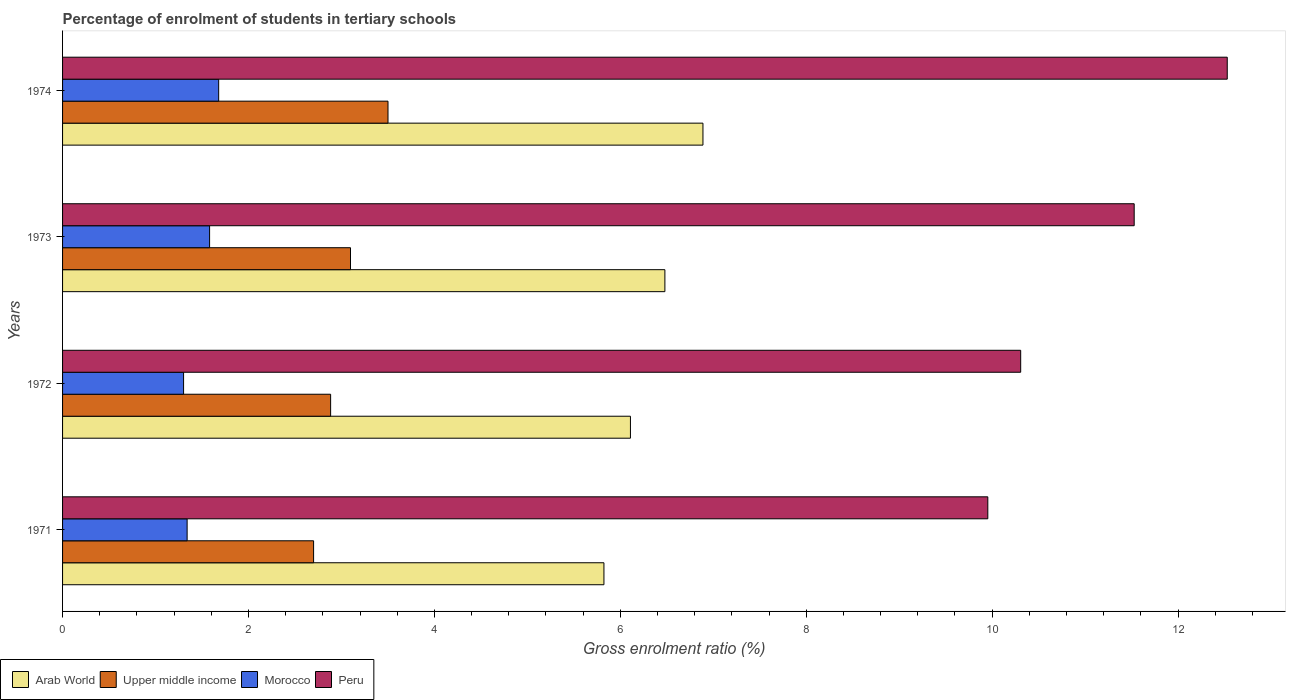How many different coloured bars are there?
Your response must be concise. 4. How many bars are there on the 1st tick from the top?
Offer a terse response. 4. What is the percentage of students enrolled in tertiary schools in Peru in 1971?
Provide a succinct answer. 9.95. Across all years, what is the maximum percentage of students enrolled in tertiary schools in Morocco?
Ensure brevity in your answer.  1.68. Across all years, what is the minimum percentage of students enrolled in tertiary schools in Morocco?
Offer a terse response. 1.3. In which year was the percentage of students enrolled in tertiary schools in Upper middle income maximum?
Your answer should be very brief. 1974. In which year was the percentage of students enrolled in tertiary schools in Upper middle income minimum?
Ensure brevity in your answer.  1971. What is the total percentage of students enrolled in tertiary schools in Upper middle income in the graph?
Your answer should be very brief. 12.18. What is the difference between the percentage of students enrolled in tertiary schools in Morocco in 1971 and that in 1972?
Your answer should be very brief. 0.04. What is the difference between the percentage of students enrolled in tertiary schools in Upper middle income in 1971 and the percentage of students enrolled in tertiary schools in Morocco in 1972?
Make the answer very short. 1.4. What is the average percentage of students enrolled in tertiary schools in Arab World per year?
Make the answer very short. 6.33. In the year 1973, what is the difference between the percentage of students enrolled in tertiary schools in Arab World and percentage of students enrolled in tertiary schools in Upper middle income?
Your answer should be compact. 3.38. In how many years, is the percentage of students enrolled in tertiary schools in Morocco greater than 5.6 %?
Your answer should be very brief. 0. What is the ratio of the percentage of students enrolled in tertiary schools in Arab World in 1972 to that in 1973?
Your response must be concise. 0.94. Is the percentage of students enrolled in tertiary schools in Arab World in 1971 less than that in 1974?
Your response must be concise. Yes. Is the difference between the percentage of students enrolled in tertiary schools in Arab World in 1971 and 1972 greater than the difference between the percentage of students enrolled in tertiary schools in Upper middle income in 1971 and 1972?
Keep it short and to the point. No. What is the difference between the highest and the second highest percentage of students enrolled in tertiary schools in Upper middle income?
Give a very brief answer. 0.4. What is the difference between the highest and the lowest percentage of students enrolled in tertiary schools in Peru?
Your answer should be very brief. 2.58. Is it the case that in every year, the sum of the percentage of students enrolled in tertiary schools in Peru and percentage of students enrolled in tertiary schools in Morocco is greater than the sum of percentage of students enrolled in tertiary schools in Upper middle income and percentage of students enrolled in tertiary schools in Arab World?
Offer a terse response. Yes. What does the 3rd bar from the top in 1973 represents?
Offer a very short reply. Upper middle income. What does the 2nd bar from the bottom in 1973 represents?
Make the answer very short. Upper middle income. Are the values on the major ticks of X-axis written in scientific E-notation?
Ensure brevity in your answer.  No. Where does the legend appear in the graph?
Your response must be concise. Bottom left. How many legend labels are there?
Offer a terse response. 4. How are the legend labels stacked?
Your answer should be compact. Horizontal. What is the title of the graph?
Your answer should be compact. Percentage of enrolment of students in tertiary schools. Does "Seychelles" appear as one of the legend labels in the graph?
Give a very brief answer. No. What is the label or title of the X-axis?
Ensure brevity in your answer.  Gross enrolment ratio (%). What is the Gross enrolment ratio (%) in Arab World in 1971?
Offer a very short reply. 5.82. What is the Gross enrolment ratio (%) in Upper middle income in 1971?
Your answer should be compact. 2.7. What is the Gross enrolment ratio (%) in Morocco in 1971?
Provide a short and direct response. 1.34. What is the Gross enrolment ratio (%) in Peru in 1971?
Offer a very short reply. 9.95. What is the Gross enrolment ratio (%) in Arab World in 1972?
Ensure brevity in your answer.  6.11. What is the Gross enrolment ratio (%) in Upper middle income in 1972?
Offer a very short reply. 2.88. What is the Gross enrolment ratio (%) of Morocco in 1972?
Ensure brevity in your answer.  1.3. What is the Gross enrolment ratio (%) of Peru in 1972?
Keep it short and to the point. 10.31. What is the Gross enrolment ratio (%) of Arab World in 1973?
Offer a terse response. 6.48. What is the Gross enrolment ratio (%) of Upper middle income in 1973?
Your answer should be very brief. 3.1. What is the Gross enrolment ratio (%) in Morocco in 1973?
Give a very brief answer. 1.58. What is the Gross enrolment ratio (%) in Peru in 1973?
Provide a succinct answer. 11.53. What is the Gross enrolment ratio (%) in Arab World in 1974?
Give a very brief answer. 6.89. What is the Gross enrolment ratio (%) of Upper middle income in 1974?
Your answer should be compact. 3.5. What is the Gross enrolment ratio (%) in Morocco in 1974?
Offer a very short reply. 1.68. What is the Gross enrolment ratio (%) of Peru in 1974?
Give a very brief answer. 12.53. Across all years, what is the maximum Gross enrolment ratio (%) of Arab World?
Your answer should be very brief. 6.89. Across all years, what is the maximum Gross enrolment ratio (%) of Upper middle income?
Provide a short and direct response. 3.5. Across all years, what is the maximum Gross enrolment ratio (%) of Morocco?
Provide a short and direct response. 1.68. Across all years, what is the maximum Gross enrolment ratio (%) in Peru?
Ensure brevity in your answer.  12.53. Across all years, what is the minimum Gross enrolment ratio (%) of Arab World?
Provide a succinct answer. 5.82. Across all years, what is the minimum Gross enrolment ratio (%) in Upper middle income?
Offer a very short reply. 2.7. Across all years, what is the minimum Gross enrolment ratio (%) of Morocco?
Your answer should be very brief. 1.3. Across all years, what is the minimum Gross enrolment ratio (%) of Peru?
Your response must be concise. 9.95. What is the total Gross enrolment ratio (%) in Arab World in the graph?
Give a very brief answer. 25.3. What is the total Gross enrolment ratio (%) in Upper middle income in the graph?
Keep it short and to the point. 12.18. What is the total Gross enrolment ratio (%) in Morocco in the graph?
Your response must be concise. 5.9. What is the total Gross enrolment ratio (%) of Peru in the graph?
Offer a terse response. 44.32. What is the difference between the Gross enrolment ratio (%) in Arab World in 1971 and that in 1972?
Ensure brevity in your answer.  -0.29. What is the difference between the Gross enrolment ratio (%) in Upper middle income in 1971 and that in 1972?
Ensure brevity in your answer.  -0.18. What is the difference between the Gross enrolment ratio (%) in Morocco in 1971 and that in 1972?
Your response must be concise. 0.04. What is the difference between the Gross enrolment ratio (%) of Peru in 1971 and that in 1972?
Offer a very short reply. -0.35. What is the difference between the Gross enrolment ratio (%) of Arab World in 1971 and that in 1973?
Provide a succinct answer. -0.66. What is the difference between the Gross enrolment ratio (%) in Upper middle income in 1971 and that in 1973?
Offer a terse response. -0.4. What is the difference between the Gross enrolment ratio (%) of Morocco in 1971 and that in 1973?
Offer a terse response. -0.24. What is the difference between the Gross enrolment ratio (%) of Peru in 1971 and that in 1973?
Keep it short and to the point. -1.57. What is the difference between the Gross enrolment ratio (%) of Arab World in 1971 and that in 1974?
Your response must be concise. -1.07. What is the difference between the Gross enrolment ratio (%) in Upper middle income in 1971 and that in 1974?
Keep it short and to the point. -0.8. What is the difference between the Gross enrolment ratio (%) of Morocco in 1971 and that in 1974?
Offer a very short reply. -0.34. What is the difference between the Gross enrolment ratio (%) in Peru in 1971 and that in 1974?
Your answer should be compact. -2.58. What is the difference between the Gross enrolment ratio (%) in Arab World in 1972 and that in 1973?
Your answer should be compact. -0.37. What is the difference between the Gross enrolment ratio (%) in Upper middle income in 1972 and that in 1973?
Offer a very short reply. -0.21. What is the difference between the Gross enrolment ratio (%) in Morocco in 1972 and that in 1973?
Offer a very short reply. -0.28. What is the difference between the Gross enrolment ratio (%) in Peru in 1972 and that in 1973?
Offer a terse response. -1.22. What is the difference between the Gross enrolment ratio (%) in Arab World in 1972 and that in 1974?
Offer a terse response. -0.78. What is the difference between the Gross enrolment ratio (%) of Upper middle income in 1972 and that in 1974?
Your answer should be compact. -0.62. What is the difference between the Gross enrolment ratio (%) of Morocco in 1972 and that in 1974?
Ensure brevity in your answer.  -0.38. What is the difference between the Gross enrolment ratio (%) of Peru in 1972 and that in 1974?
Keep it short and to the point. -2.22. What is the difference between the Gross enrolment ratio (%) in Arab World in 1973 and that in 1974?
Keep it short and to the point. -0.41. What is the difference between the Gross enrolment ratio (%) of Upper middle income in 1973 and that in 1974?
Offer a very short reply. -0.4. What is the difference between the Gross enrolment ratio (%) in Morocco in 1973 and that in 1974?
Make the answer very short. -0.1. What is the difference between the Gross enrolment ratio (%) in Peru in 1973 and that in 1974?
Keep it short and to the point. -1. What is the difference between the Gross enrolment ratio (%) in Arab World in 1971 and the Gross enrolment ratio (%) in Upper middle income in 1972?
Your answer should be compact. 2.94. What is the difference between the Gross enrolment ratio (%) of Arab World in 1971 and the Gross enrolment ratio (%) of Morocco in 1972?
Keep it short and to the point. 4.52. What is the difference between the Gross enrolment ratio (%) in Arab World in 1971 and the Gross enrolment ratio (%) in Peru in 1972?
Your answer should be very brief. -4.48. What is the difference between the Gross enrolment ratio (%) of Upper middle income in 1971 and the Gross enrolment ratio (%) of Morocco in 1972?
Your answer should be very brief. 1.4. What is the difference between the Gross enrolment ratio (%) in Upper middle income in 1971 and the Gross enrolment ratio (%) in Peru in 1972?
Provide a succinct answer. -7.61. What is the difference between the Gross enrolment ratio (%) in Morocco in 1971 and the Gross enrolment ratio (%) in Peru in 1972?
Offer a terse response. -8.97. What is the difference between the Gross enrolment ratio (%) in Arab World in 1971 and the Gross enrolment ratio (%) in Upper middle income in 1973?
Make the answer very short. 2.73. What is the difference between the Gross enrolment ratio (%) in Arab World in 1971 and the Gross enrolment ratio (%) in Morocco in 1973?
Provide a short and direct response. 4.24. What is the difference between the Gross enrolment ratio (%) of Arab World in 1971 and the Gross enrolment ratio (%) of Peru in 1973?
Ensure brevity in your answer.  -5.7. What is the difference between the Gross enrolment ratio (%) of Upper middle income in 1971 and the Gross enrolment ratio (%) of Morocco in 1973?
Keep it short and to the point. 1.12. What is the difference between the Gross enrolment ratio (%) in Upper middle income in 1971 and the Gross enrolment ratio (%) in Peru in 1973?
Offer a very short reply. -8.83. What is the difference between the Gross enrolment ratio (%) in Morocco in 1971 and the Gross enrolment ratio (%) in Peru in 1973?
Provide a succinct answer. -10.19. What is the difference between the Gross enrolment ratio (%) in Arab World in 1971 and the Gross enrolment ratio (%) in Upper middle income in 1974?
Your answer should be very brief. 2.32. What is the difference between the Gross enrolment ratio (%) of Arab World in 1971 and the Gross enrolment ratio (%) of Morocco in 1974?
Make the answer very short. 4.14. What is the difference between the Gross enrolment ratio (%) of Arab World in 1971 and the Gross enrolment ratio (%) of Peru in 1974?
Your answer should be compact. -6.71. What is the difference between the Gross enrolment ratio (%) of Upper middle income in 1971 and the Gross enrolment ratio (%) of Morocco in 1974?
Provide a short and direct response. 1.02. What is the difference between the Gross enrolment ratio (%) of Upper middle income in 1971 and the Gross enrolment ratio (%) of Peru in 1974?
Offer a terse response. -9.83. What is the difference between the Gross enrolment ratio (%) in Morocco in 1971 and the Gross enrolment ratio (%) in Peru in 1974?
Make the answer very short. -11.19. What is the difference between the Gross enrolment ratio (%) in Arab World in 1972 and the Gross enrolment ratio (%) in Upper middle income in 1973?
Your answer should be very brief. 3.01. What is the difference between the Gross enrolment ratio (%) of Arab World in 1972 and the Gross enrolment ratio (%) of Morocco in 1973?
Offer a terse response. 4.53. What is the difference between the Gross enrolment ratio (%) of Arab World in 1972 and the Gross enrolment ratio (%) of Peru in 1973?
Offer a very short reply. -5.42. What is the difference between the Gross enrolment ratio (%) in Upper middle income in 1972 and the Gross enrolment ratio (%) in Morocco in 1973?
Your answer should be very brief. 1.3. What is the difference between the Gross enrolment ratio (%) of Upper middle income in 1972 and the Gross enrolment ratio (%) of Peru in 1973?
Ensure brevity in your answer.  -8.64. What is the difference between the Gross enrolment ratio (%) of Morocco in 1972 and the Gross enrolment ratio (%) of Peru in 1973?
Offer a very short reply. -10.23. What is the difference between the Gross enrolment ratio (%) in Arab World in 1972 and the Gross enrolment ratio (%) in Upper middle income in 1974?
Your answer should be very brief. 2.61. What is the difference between the Gross enrolment ratio (%) of Arab World in 1972 and the Gross enrolment ratio (%) of Morocco in 1974?
Ensure brevity in your answer.  4.43. What is the difference between the Gross enrolment ratio (%) in Arab World in 1972 and the Gross enrolment ratio (%) in Peru in 1974?
Your answer should be compact. -6.42. What is the difference between the Gross enrolment ratio (%) of Upper middle income in 1972 and the Gross enrolment ratio (%) of Morocco in 1974?
Provide a short and direct response. 1.2. What is the difference between the Gross enrolment ratio (%) in Upper middle income in 1972 and the Gross enrolment ratio (%) in Peru in 1974?
Keep it short and to the point. -9.65. What is the difference between the Gross enrolment ratio (%) in Morocco in 1972 and the Gross enrolment ratio (%) in Peru in 1974?
Offer a terse response. -11.23. What is the difference between the Gross enrolment ratio (%) in Arab World in 1973 and the Gross enrolment ratio (%) in Upper middle income in 1974?
Ensure brevity in your answer.  2.98. What is the difference between the Gross enrolment ratio (%) in Arab World in 1973 and the Gross enrolment ratio (%) in Morocco in 1974?
Provide a succinct answer. 4.8. What is the difference between the Gross enrolment ratio (%) in Arab World in 1973 and the Gross enrolment ratio (%) in Peru in 1974?
Your answer should be very brief. -6.05. What is the difference between the Gross enrolment ratio (%) in Upper middle income in 1973 and the Gross enrolment ratio (%) in Morocco in 1974?
Keep it short and to the point. 1.42. What is the difference between the Gross enrolment ratio (%) of Upper middle income in 1973 and the Gross enrolment ratio (%) of Peru in 1974?
Ensure brevity in your answer.  -9.43. What is the difference between the Gross enrolment ratio (%) in Morocco in 1973 and the Gross enrolment ratio (%) in Peru in 1974?
Offer a very short reply. -10.95. What is the average Gross enrolment ratio (%) in Arab World per year?
Your answer should be very brief. 6.33. What is the average Gross enrolment ratio (%) of Upper middle income per year?
Your answer should be very brief. 3.05. What is the average Gross enrolment ratio (%) in Morocco per year?
Provide a succinct answer. 1.48. What is the average Gross enrolment ratio (%) in Peru per year?
Provide a short and direct response. 11.08. In the year 1971, what is the difference between the Gross enrolment ratio (%) in Arab World and Gross enrolment ratio (%) in Upper middle income?
Offer a terse response. 3.12. In the year 1971, what is the difference between the Gross enrolment ratio (%) of Arab World and Gross enrolment ratio (%) of Morocco?
Keep it short and to the point. 4.48. In the year 1971, what is the difference between the Gross enrolment ratio (%) in Arab World and Gross enrolment ratio (%) in Peru?
Your response must be concise. -4.13. In the year 1971, what is the difference between the Gross enrolment ratio (%) in Upper middle income and Gross enrolment ratio (%) in Morocco?
Offer a very short reply. 1.36. In the year 1971, what is the difference between the Gross enrolment ratio (%) of Upper middle income and Gross enrolment ratio (%) of Peru?
Your response must be concise. -7.25. In the year 1971, what is the difference between the Gross enrolment ratio (%) of Morocco and Gross enrolment ratio (%) of Peru?
Give a very brief answer. -8.61. In the year 1972, what is the difference between the Gross enrolment ratio (%) in Arab World and Gross enrolment ratio (%) in Upper middle income?
Your answer should be very brief. 3.23. In the year 1972, what is the difference between the Gross enrolment ratio (%) in Arab World and Gross enrolment ratio (%) in Morocco?
Provide a short and direct response. 4.81. In the year 1972, what is the difference between the Gross enrolment ratio (%) in Arab World and Gross enrolment ratio (%) in Peru?
Your response must be concise. -4.2. In the year 1972, what is the difference between the Gross enrolment ratio (%) of Upper middle income and Gross enrolment ratio (%) of Morocco?
Give a very brief answer. 1.58. In the year 1972, what is the difference between the Gross enrolment ratio (%) of Upper middle income and Gross enrolment ratio (%) of Peru?
Give a very brief answer. -7.42. In the year 1972, what is the difference between the Gross enrolment ratio (%) in Morocco and Gross enrolment ratio (%) in Peru?
Provide a succinct answer. -9.01. In the year 1973, what is the difference between the Gross enrolment ratio (%) of Arab World and Gross enrolment ratio (%) of Upper middle income?
Keep it short and to the point. 3.38. In the year 1973, what is the difference between the Gross enrolment ratio (%) in Arab World and Gross enrolment ratio (%) in Morocco?
Provide a short and direct response. 4.9. In the year 1973, what is the difference between the Gross enrolment ratio (%) of Arab World and Gross enrolment ratio (%) of Peru?
Make the answer very short. -5.05. In the year 1973, what is the difference between the Gross enrolment ratio (%) of Upper middle income and Gross enrolment ratio (%) of Morocco?
Your answer should be very brief. 1.52. In the year 1973, what is the difference between the Gross enrolment ratio (%) of Upper middle income and Gross enrolment ratio (%) of Peru?
Keep it short and to the point. -8.43. In the year 1973, what is the difference between the Gross enrolment ratio (%) in Morocco and Gross enrolment ratio (%) in Peru?
Make the answer very short. -9.95. In the year 1974, what is the difference between the Gross enrolment ratio (%) of Arab World and Gross enrolment ratio (%) of Upper middle income?
Your answer should be compact. 3.39. In the year 1974, what is the difference between the Gross enrolment ratio (%) of Arab World and Gross enrolment ratio (%) of Morocco?
Your answer should be compact. 5.21. In the year 1974, what is the difference between the Gross enrolment ratio (%) in Arab World and Gross enrolment ratio (%) in Peru?
Offer a terse response. -5.64. In the year 1974, what is the difference between the Gross enrolment ratio (%) of Upper middle income and Gross enrolment ratio (%) of Morocco?
Offer a very short reply. 1.82. In the year 1974, what is the difference between the Gross enrolment ratio (%) of Upper middle income and Gross enrolment ratio (%) of Peru?
Your answer should be very brief. -9.03. In the year 1974, what is the difference between the Gross enrolment ratio (%) of Morocco and Gross enrolment ratio (%) of Peru?
Provide a short and direct response. -10.85. What is the ratio of the Gross enrolment ratio (%) of Arab World in 1971 to that in 1972?
Your response must be concise. 0.95. What is the ratio of the Gross enrolment ratio (%) of Upper middle income in 1971 to that in 1972?
Provide a succinct answer. 0.94. What is the ratio of the Gross enrolment ratio (%) of Morocco in 1971 to that in 1972?
Your response must be concise. 1.03. What is the ratio of the Gross enrolment ratio (%) of Peru in 1971 to that in 1972?
Offer a very short reply. 0.97. What is the ratio of the Gross enrolment ratio (%) in Arab World in 1971 to that in 1973?
Provide a succinct answer. 0.9. What is the ratio of the Gross enrolment ratio (%) of Upper middle income in 1971 to that in 1973?
Provide a short and direct response. 0.87. What is the ratio of the Gross enrolment ratio (%) of Morocco in 1971 to that in 1973?
Provide a succinct answer. 0.85. What is the ratio of the Gross enrolment ratio (%) in Peru in 1971 to that in 1973?
Make the answer very short. 0.86. What is the ratio of the Gross enrolment ratio (%) in Arab World in 1971 to that in 1974?
Provide a short and direct response. 0.85. What is the ratio of the Gross enrolment ratio (%) in Upper middle income in 1971 to that in 1974?
Your response must be concise. 0.77. What is the ratio of the Gross enrolment ratio (%) of Morocco in 1971 to that in 1974?
Provide a short and direct response. 0.8. What is the ratio of the Gross enrolment ratio (%) in Peru in 1971 to that in 1974?
Your response must be concise. 0.79. What is the ratio of the Gross enrolment ratio (%) in Arab World in 1972 to that in 1973?
Your response must be concise. 0.94. What is the ratio of the Gross enrolment ratio (%) in Morocco in 1972 to that in 1973?
Make the answer very short. 0.82. What is the ratio of the Gross enrolment ratio (%) in Peru in 1972 to that in 1973?
Provide a succinct answer. 0.89. What is the ratio of the Gross enrolment ratio (%) in Arab World in 1972 to that in 1974?
Offer a terse response. 0.89. What is the ratio of the Gross enrolment ratio (%) in Upper middle income in 1972 to that in 1974?
Provide a short and direct response. 0.82. What is the ratio of the Gross enrolment ratio (%) of Morocco in 1972 to that in 1974?
Offer a very short reply. 0.78. What is the ratio of the Gross enrolment ratio (%) in Peru in 1972 to that in 1974?
Offer a terse response. 0.82. What is the ratio of the Gross enrolment ratio (%) of Arab World in 1973 to that in 1974?
Give a very brief answer. 0.94. What is the ratio of the Gross enrolment ratio (%) of Upper middle income in 1973 to that in 1974?
Your answer should be compact. 0.88. What is the ratio of the Gross enrolment ratio (%) of Morocco in 1973 to that in 1974?
Keep it short and to the point. 0.94. What is the ratio of the Gross enrolment ratio (%) of Peru in 1973 to that in 1974?
Make the answer very short. 0.92. What is the difference between the highest and the second highest Gross enrolment ratio (%) of Arab World?
Keep it short and to the point. 0.41. What is the difference between the highest and the second highest Gross enrolment ratio (%) in Upper middle income?
Offer a very short reply. 0.4. What is the difference between the highest and the second highest Gross enrolment ratio (%) of Morocco?
Ensure brevity in your answer.  0.1. What is the difference between the highest and the lowest Gross enrolment ratio (%) in Arab World?
Provide a short and direct response. 1.07. What is the difference between the highest and the lowest Gross enrolment ratio (%) in Upper middle income?
Offer a terse response. 0.8. What is the difference between the highest and the lowest Gross enrolment ratio (%) in Morocco?
Offer a very short reply. 0.38. What is the difference between the highest and the lowest Gross enrolment ratio (%) of Peru?
Make the answer very short. 2.58. 